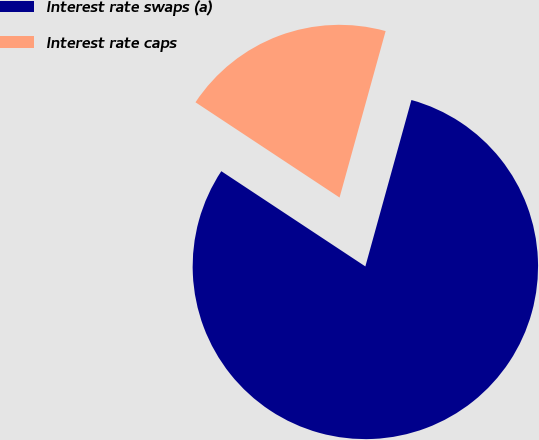Convert chart to OTSL. <chart><loc_0><loc_0><loc_500><loc_500><pie_chart><fcel>Interest rate swaps (a)<fcel>Interest rate caps<nl><fcel>80.0%<fcel>20.0%<nl></chart> 